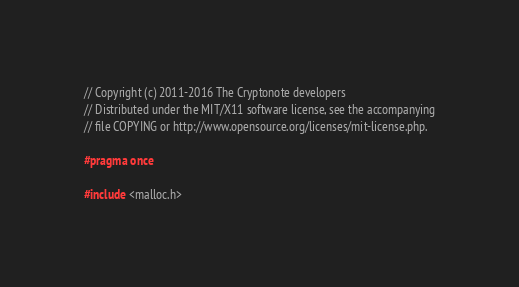<code> <loc_0><loc_0><loc_500><loc_500><_C_>// Copyright (c) 2011-2016 The Cryptonote developers
// Distributed under the MIT/X11 software license, see the accompanying
// file COPYING or http://www.opensource.org/licenses/mit-license.php.

#pragma once

#include <malloc.h>
</code> 